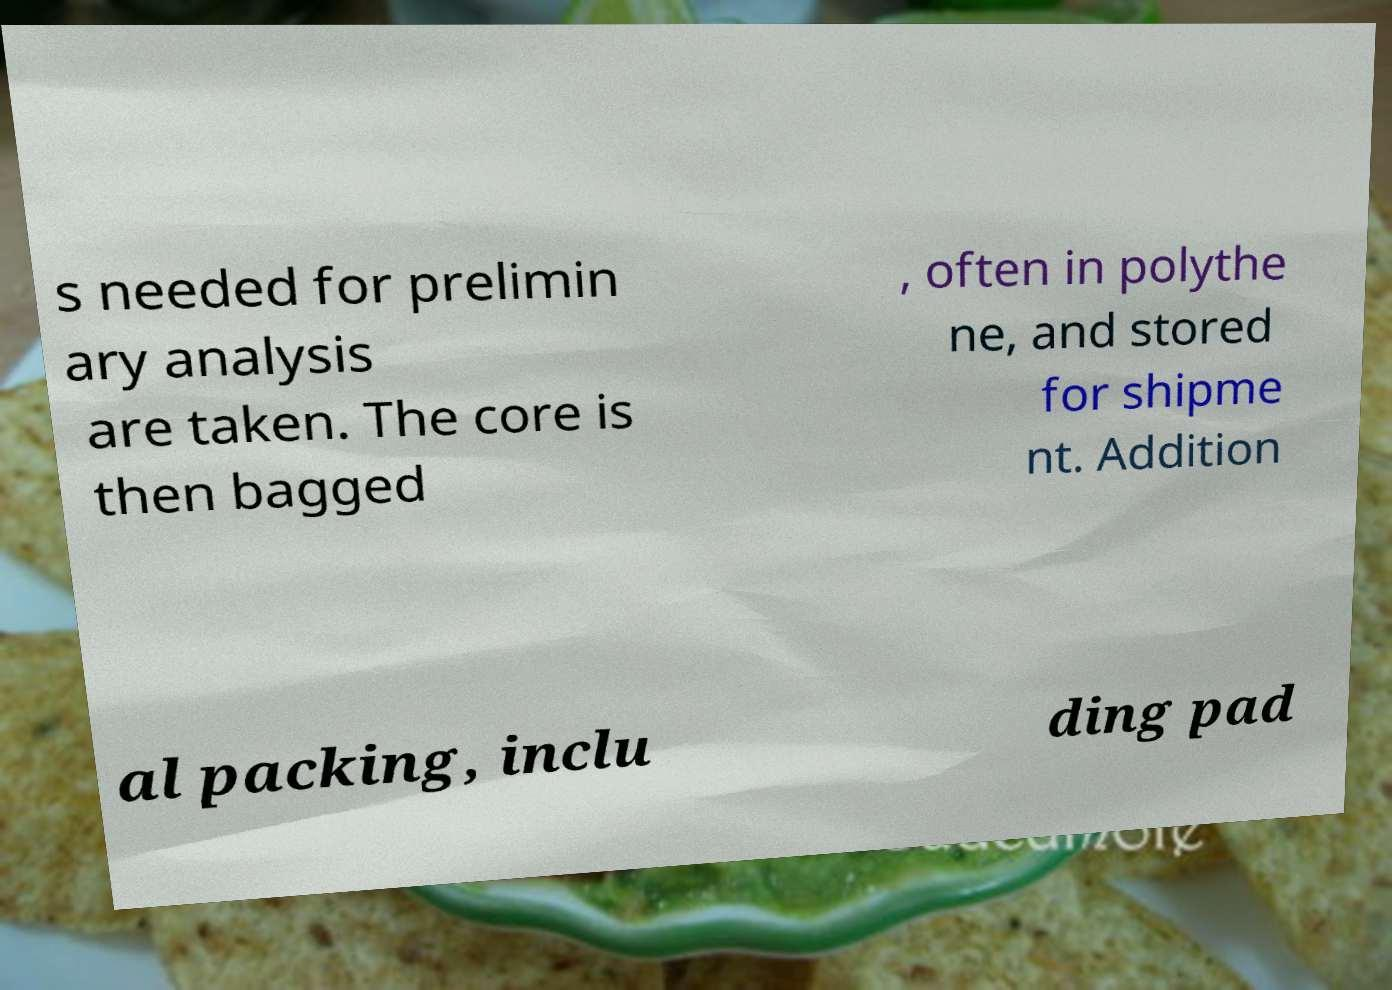Could you extract and type out the text from this image? s needed for prelimin ary analysis are taken. The core is then bagged , often in polythe ne, and stored for shipme nt. Addition al packing, inclu ding pad 